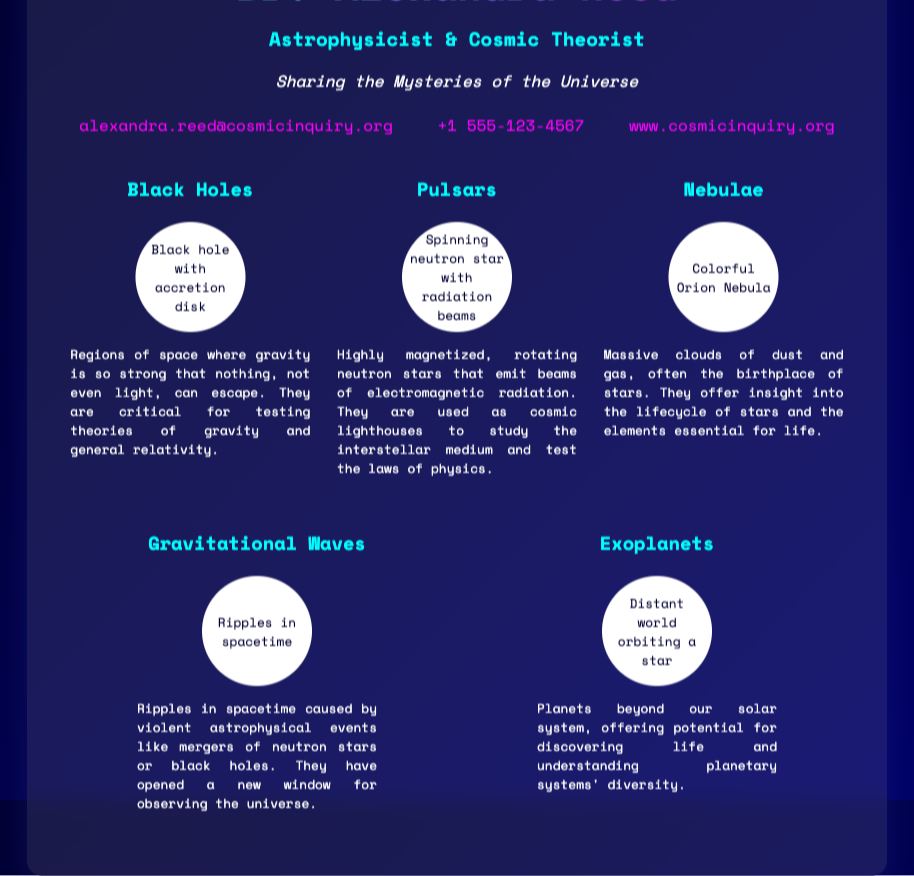What is the name of the astrophysicist? The name of the astrophysicist is prominently displayed at the top of the business card.
Answer: Dr. Alexandra Reed What is the email address listed? The email address can be found in the contact section of the document.
Answer: alexandra.reed@cosmicinquiry.org How many astrophysical phenomena are mentioned? There are five distinct phenomena described in the document.
Answer: 5 Which phenomenon is described as regions of space where gravity is so strong that nothing can escape? This detail is found in the description of the corresponding phenomenon section.
Answer: Black Holes What is the artwork associated with the Pulsars phenomenon? The specific artwork is noted right beneath the title for Pulsars.
Answer: Spinning neutron star with radiation beams What do Nebulae represent in astrophysics? The explanation of Nebulae provides insight into their significance in the universe.
Answer: Birthplace of stars Which phenomenon has opened a new window for observing the universe? The introduction of this idea is found in the description of Gravitational Waves.
Answer: Gravitational Waves What is the primary focus of Dr. Alexandra Reed as per the description? The description outlines the main thematic goal of the astrophysicist.
Answer: Sharing the Mysteries of the Universe What is the maximum width of the business card? The maximum width is described in the styling of the document.
Answer: 800px 